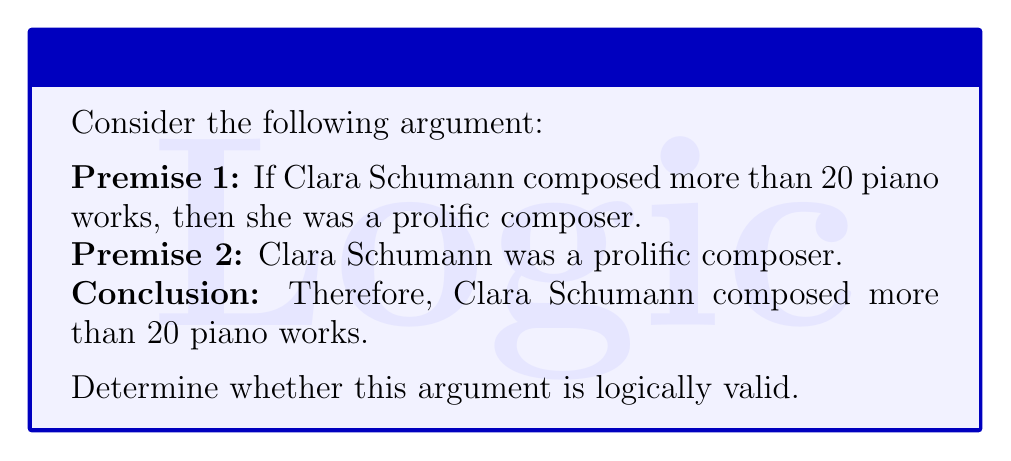Show me your answer to this math problem. To determine the logical validity of this argument, we need to analyze its structure and use the principles of propositional logic. Let's break it down step by step:

1. Let's define our propositions:
   P: Clara Schumann composed more than 20 piano works
   Q: Clara Schumann was a prolific composer

2. Now, we can rewrite the argument in symbolic form:
   Premise 1: $P \rightarrow Q$
   Premise 2: $Q$
   Conclusion: $\therefore P$

3. This argument structure is known as the fallacy of affirming the consequent. It has the general form:
   $$(P \rightarrow Q) \land Q \therefore P$$

4. To prove that this argument is not logically valid, we need to show that it's possible for the premises to be true while the conclusion is false. Let's construct a truth table:

   $$\begin{array}{|c|c|c|c|c|}
   \hline
   P & Q & P \rightarrow Q & (P \rightarrow Q) \land Q & \text{Conclusion} \\
   \hline
   T & T & T & T & T \\
   T & F & F & F & T \\
   F & T & T & T & F \\
   F & F & T & F & F \\
   \hline
   \end{array}$$

5. In the third row of the truth table, we can see that it's possible for both premises to be true ($(P \rightarrow Q) \land Q$ is true) while the conclusion is false (P is false).

6. This demonstrates that the argument is not logically valid because there exists a scenario where the premises are true but the conclusion is false.

7. In the context of Clara Schumann, this means that even if it's true that composing more than 20 piano works would make her a prolific composer, and it's also true that she was a prolific composer, we cannot logically conclude that she necessarily composed more than 20 piano works. She could have been prolific in other ways, such as composing many works in other genres or being a frequent performer.
Answer: The argument is not logically valid. It commits the fallacy of affirming the consequent. 